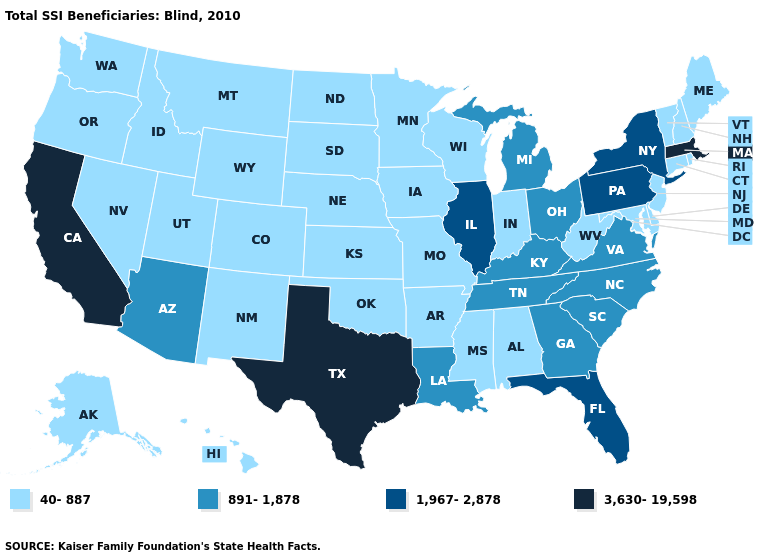Does West Virginia have the same value as Illinois?
Keep it brief. No. Does Massachusetts have the highest value in the USA?
Keep it brief. Yes. What is the value of Delaware?
Keep it brief. 40-887. What is the highest value in states that border Mississippi?
Give a very brief answer. 891-1,878. Name the states that have a value in the range 891-1,878?
Concise answer only. Arizona, Georgia, Kentucky, Louisiana, Michigan, North Carolina, Ohio, South Carolina, Tennessee, Virginia. Does Idaho have the lowest value in the West?
Quick response, please. Yes. Does the first symbol in the legend represent the smallest category?
Be succinct. Yes. What is the lowest value in the South?
Answer briefly. 40-887. Which states have the highest value in the USA?
Be succinct. California, Massachusetts, Texas. Does the map have missing data?
Concise answer only. No. Does Wisconsin have the highest value in the MidWest?
Be succinct. No. What is the lowest value in the Northeast?
Write a very short answer. 40-887. Which states hav the highest value in the MidWest?
Give a very brief answer. Illinois. Does Idaho have the same value as Illinois?
Concise answer only. No. 